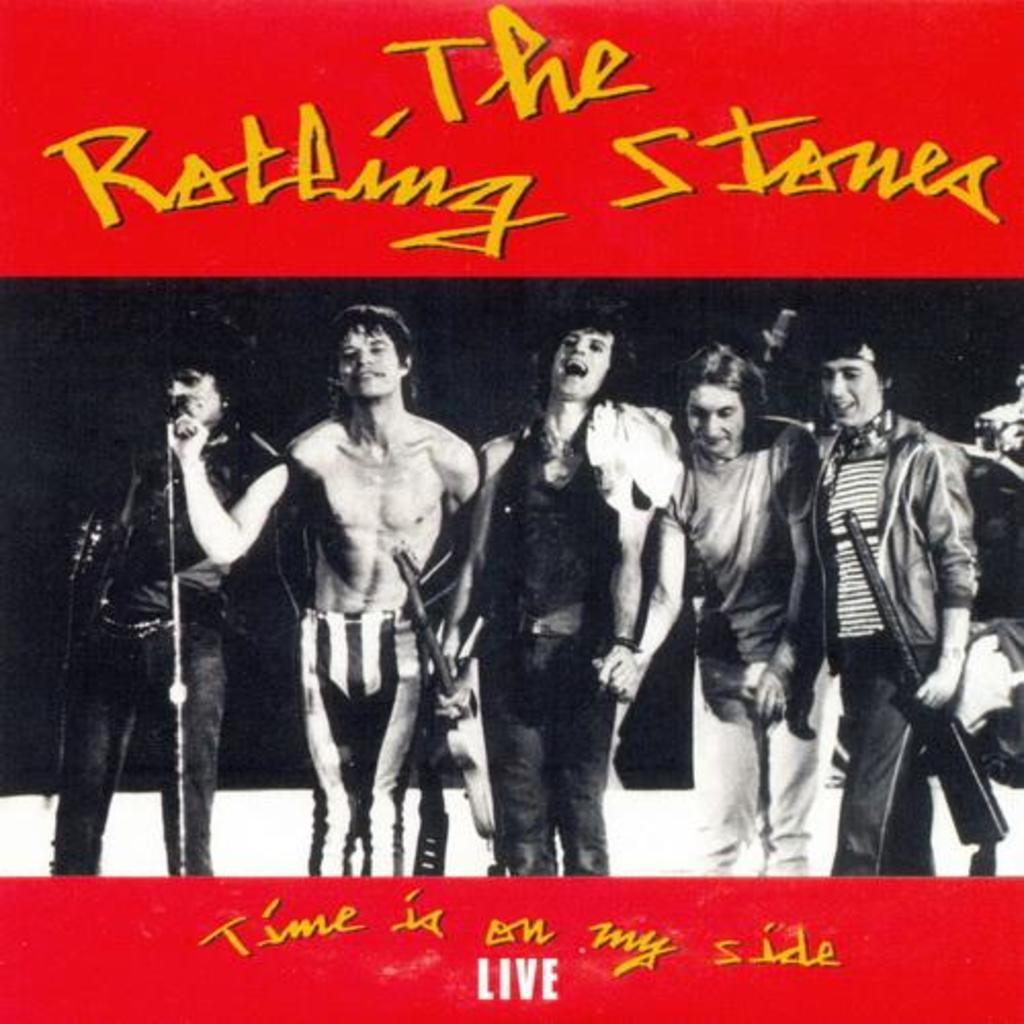In one or two sentences, can you explain what this image depicts? In the image we can see there are people standing, wearing clothes. This is a microphone, guitar and other object. This is a text. 